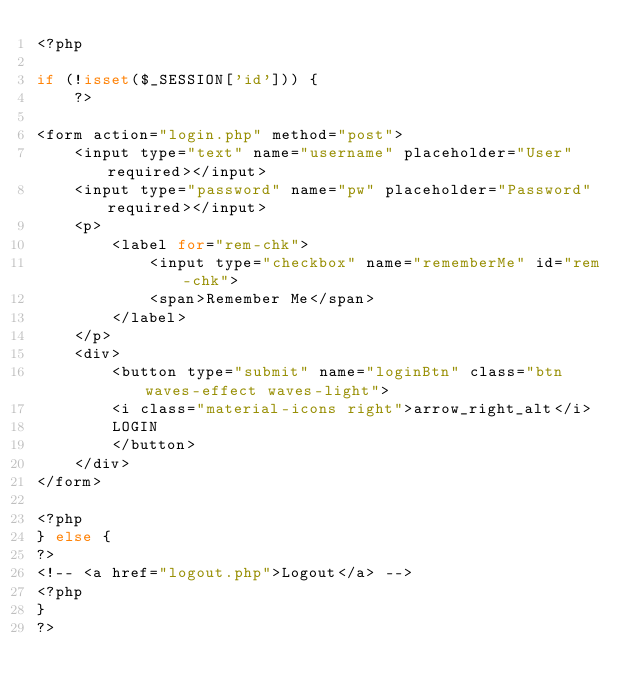<code> <loc_0><loc_0><loc_500><loc_500><_PHP_><?php

if (!isset($_SESSION['id'])) {
    ?>

<form action="login.php" method="post">
    <input type="text" name="username" placeholder="User" required></input>
    <input type="password" name="pw" placeholder="Password" required></input>
    <p>
        <label for="rem-chk">
            <input type="checkbox" name="rememberMe" id="rem-chk">
            <span>Remember Me</span>
        </label>
    </p>
    <div>
        <button type="submit" name="loginBtn" class="btn waves-effect waves-light">
        <i class="material-icons right">arrow_right_alt</i>
        LOGIN
        </button>
    </div>
</form>

<?php
} else {
?>
<!-- <a href="logout.php">Logout</a> -->
<?php
}
?></code> 